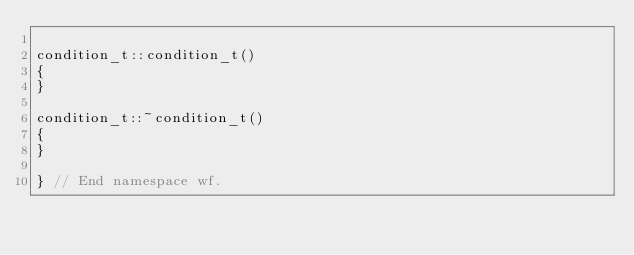Convert code to text. <code><loc_0><loc_0><loc_500><loc_500><_C++_>
condition_t::condition_t()
{
}

condition_t::~condition_t()
{
}

} // End namespace wf.
</code> 